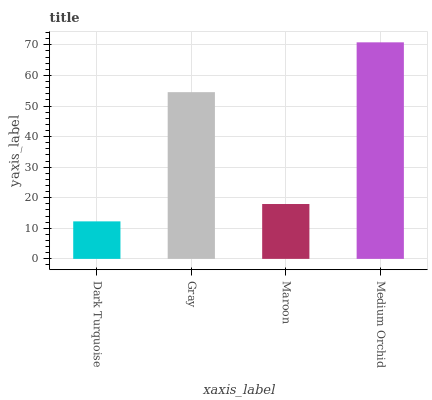Is Dark Turquoise the minimum?
Answer yes or no. Yes. Is Medium Orchid the maximum?
Answer yes or no. Yes. Is Gray the minimum?
Answer yes or no. No. Is Gray the maximum?
Answer yes or no. No. Is Gray greater than Dark Turquoise?
Answer yes or no. Yes. Is Dark Turquoise less than Gray?
Answer yes or no. Yes. Is Dark Turquoise greater than Gray?
Answer yes or no. No. Is Gray less than Dark Turquoise?
Answer yes or no. No. Is Gray the high median?
Answer yes or no. Yes. Is Maroon the low median?
Answer yes or no. Yes. Is Dark Turquoise the high median?
Answer yes or no. No. Is Gray the low median?
Answer yes or no. No. 